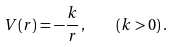<formula> <loc_0><loc_0><loc_500><loc_500>V ( r ) = - \frac { k } { r } \, , \quad ( k > 0 ) \, .</formula> 